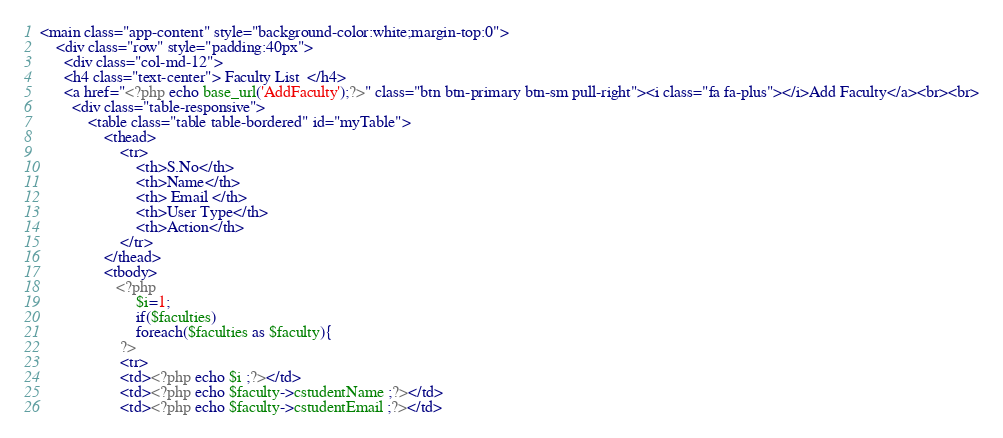Convert code to text. <code><loc_0><loc_0><loc_500><loc_500><_PHP_><main class="app-content" style="background-color:white;margin-top:0">
    <div class="row" style="padding:40px">
      <div class="col-md-12">
      <h4 class="text-center"> Faculty List  </h4>
      <a href="<?php echo base_url('AddFaculty');?>" class="btn btn-primary btn-sm pull-right"><i class="fa fa-plus"></i>Add Faculty</a><br><br>
        <div class="table-responsive">
            <table class="table table-bordered" id="myTable">
                <thead>
                    <tr>
                        <th>S.No</th>
                        <th>Name</th>
                        <th> Email </th>
                        <th>User Type</th>
                        <th>Action</th>
                    </tr>
                </thead>
                <tbody>
                   <?php 
                        $i=1;
                        if($faculties)
                        foreach($faculties as $faculty){
                    ?>
                    <tr>
                    <td><?php echo $i ;?></td>
                    <td><?php echo $faculty->cstudentName ;?></td>
                    <td><?php echo $faculty->cstudentEmail ;?></td></code> 